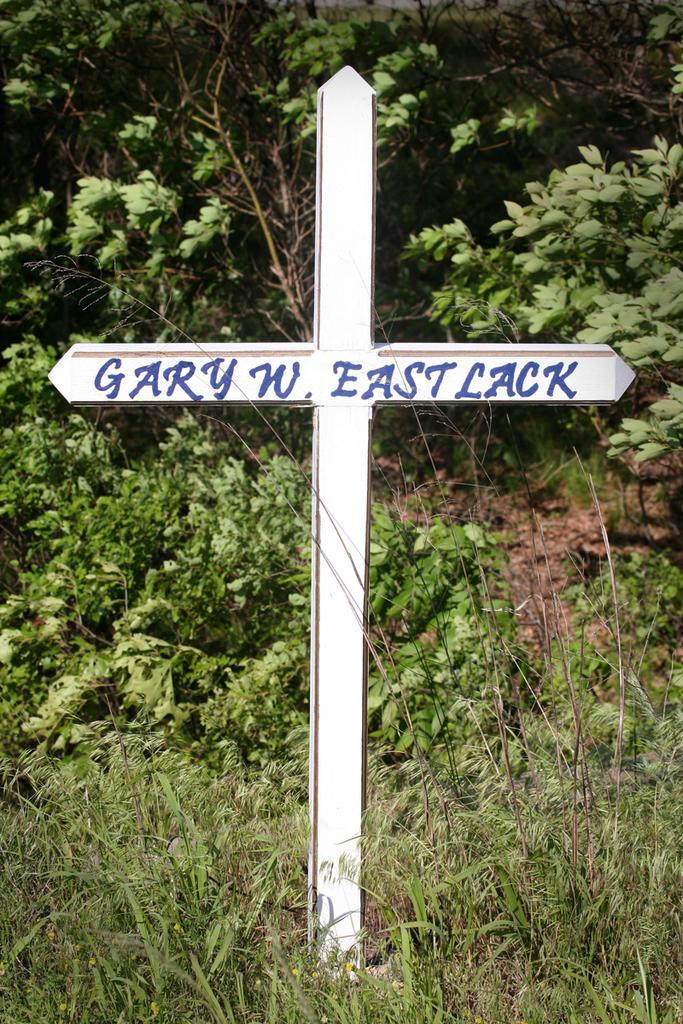What is the main object in the picture? There is a cross in the picture. Is there any text or writing on the cross? Yes, something is written on the cross. What can be seen in the background of the picture? There is grass and plants in the background of the picture. What type of meat is being served on the shirt in the picture? There is no meat or shirt present in the picture; it features a cross with writing and a background of grass and plants. 